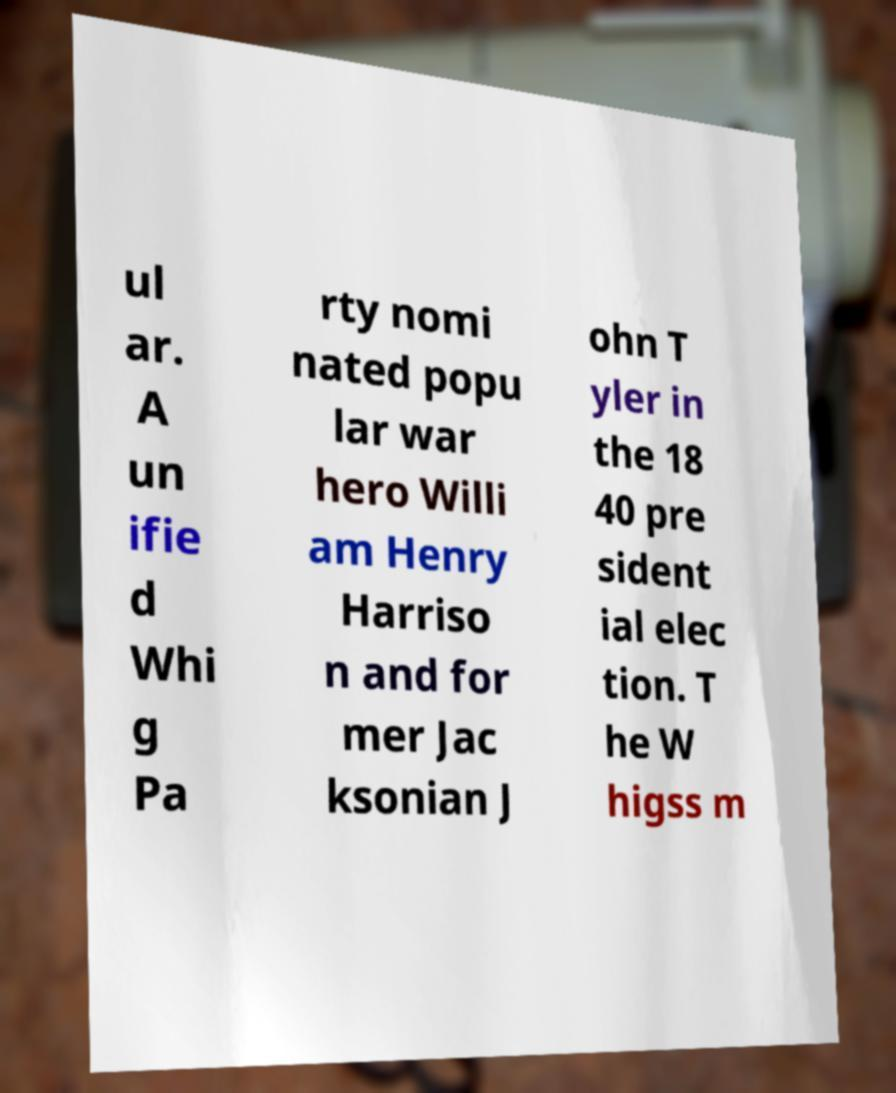Could you extract and type out the text from this image? ul ar. A un ifie d Whi g Pa rty nomi nated popu lar war hero Willi am Henry Harriso n and for mer Jac ksonian J ohn T yler in the 18 40 pre sident ial elec tion. T he W higss m 